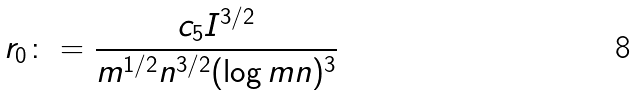<formula> <loc_0><loc_0><loc_500><loc_500>r _ { 0 } \colon = \frac { c _ { 5 } I ^ { 3 / 2 } } { m ^ { 1 / 2 } n ^ { 3 / 2 } ( \log m n ) ^ { 3 } }</formula> 